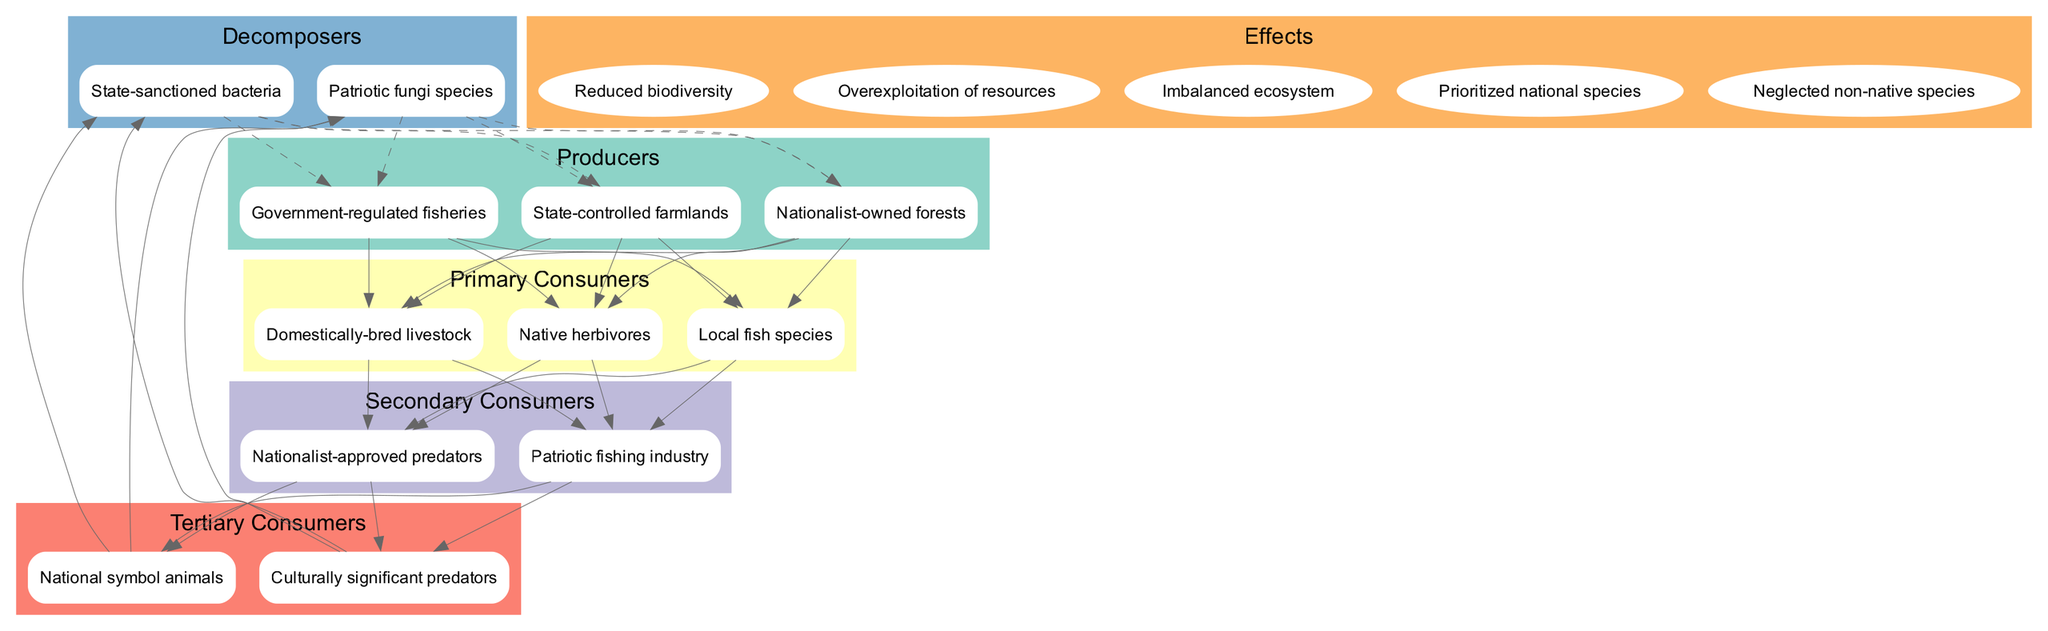What are the producers in the diagram? The producers are the first level in the food chain, listed as State-controlled farmlands, Nationalist-owned forests, and Government-regulated fisheries. These items are categorized under the producers section of the diagram.
Answer: State-controlled farmlands, Nationalist-owned forests, Government-regulated fisheries How many primary consumers are there? The primary consumers are the second level in the food chain, and there are three of them: Domestically-bred livestock, Native herbivores, and Local fish species. Therefore, to find the total, we count these items.
Answer: 3 Which node connects to Nationalist-approved predators? Nationalist-approved predators is in the secondary consumer section, connected to primary consumers. The primary consumers listed are Domestically-bred livestock, Native herbivores, and Local fish species, which all connect to Nationalist-approved predators.
Answer: Domestically-bred livestock, Native herbivores, Local fish species What is the effect of Nationalist resource policies on biodiversity? One of the listed effects shows that Nationalist resource policies lead to Reduced biodiversity. This information directly associates with the impact of nationalist resource policies reflected in the effects section of the diagram.
Answer: Reduced biodiversity Which component connects directly to state-sanctioned bacteria? The decomposers like state-sanctioned bacteria connect directly to the producers. From the diagram's structure, the edges demonstrate that state-sanctioned bacteria feed off the producers.
Answer: State-controlled farmlands, Nationalist-owned forests, Government-regulated fisheries What impacts arise from prioritizing national species? The diagram indicates that prioritizing national species leads to certain negative impacts including Reduced biodiversity, Overexploitation of resources, and Neglected non-native species among the effects listed. Therefore, these consequences stem from such prioritization.
Answer: Reduced biodiversity, Overexploitation of resources, Neglected non-native species How many tertiary consumers are depicted in the diagram? The tertiary consumers section includes National symbol animals and Culturally significant predators, totaling two distinct items. To find the number, we count these two listed items.
Answer: 2 Which decomposer is associated with patriotic fungi species? Patriotic fungi species is one of the decomposers in the diagram. All decomposers, including patriotic fungi species, connect back to producers and complete the food chain cycle as indicated in the connections.
Answer: State-controlled farmlands, Nationalist-owned forests, Government-regulated fisheries 